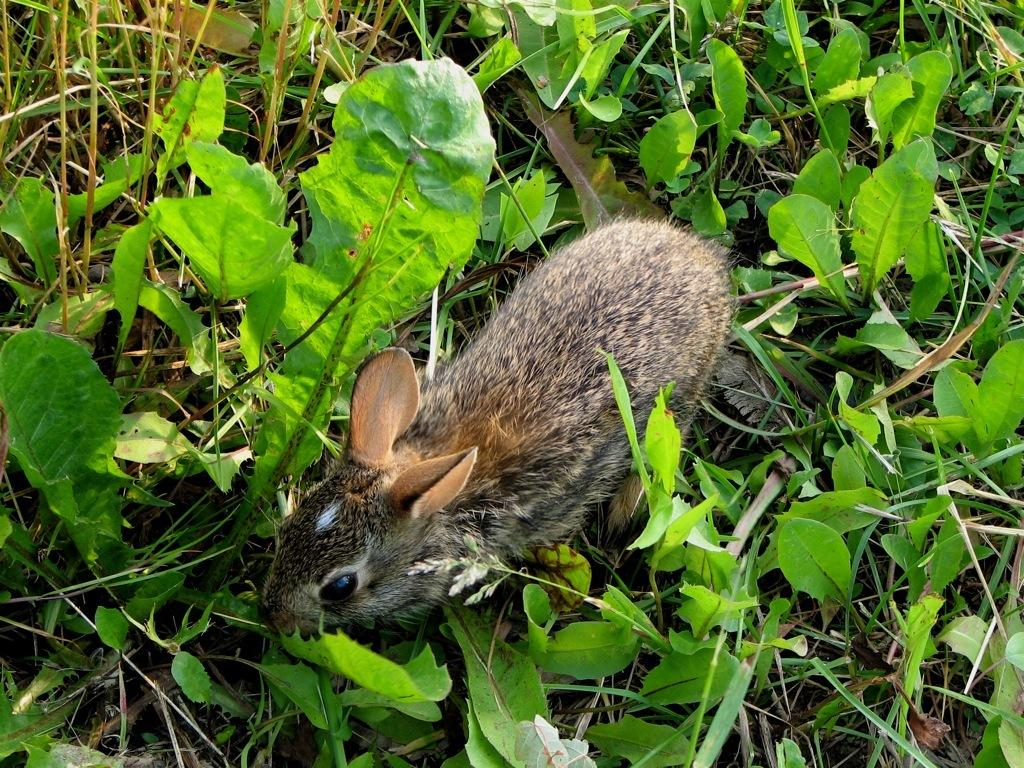What type of creature can be seen in the image? There is an animal in the image. Where is the animal located? The animal is on the ground. What else is present in the image besides the animal? There are plants in the image. What type of cream can be seen on the police officer's uniform in the image? There is no police officer or cream present in the image; it features an animal and plants. 